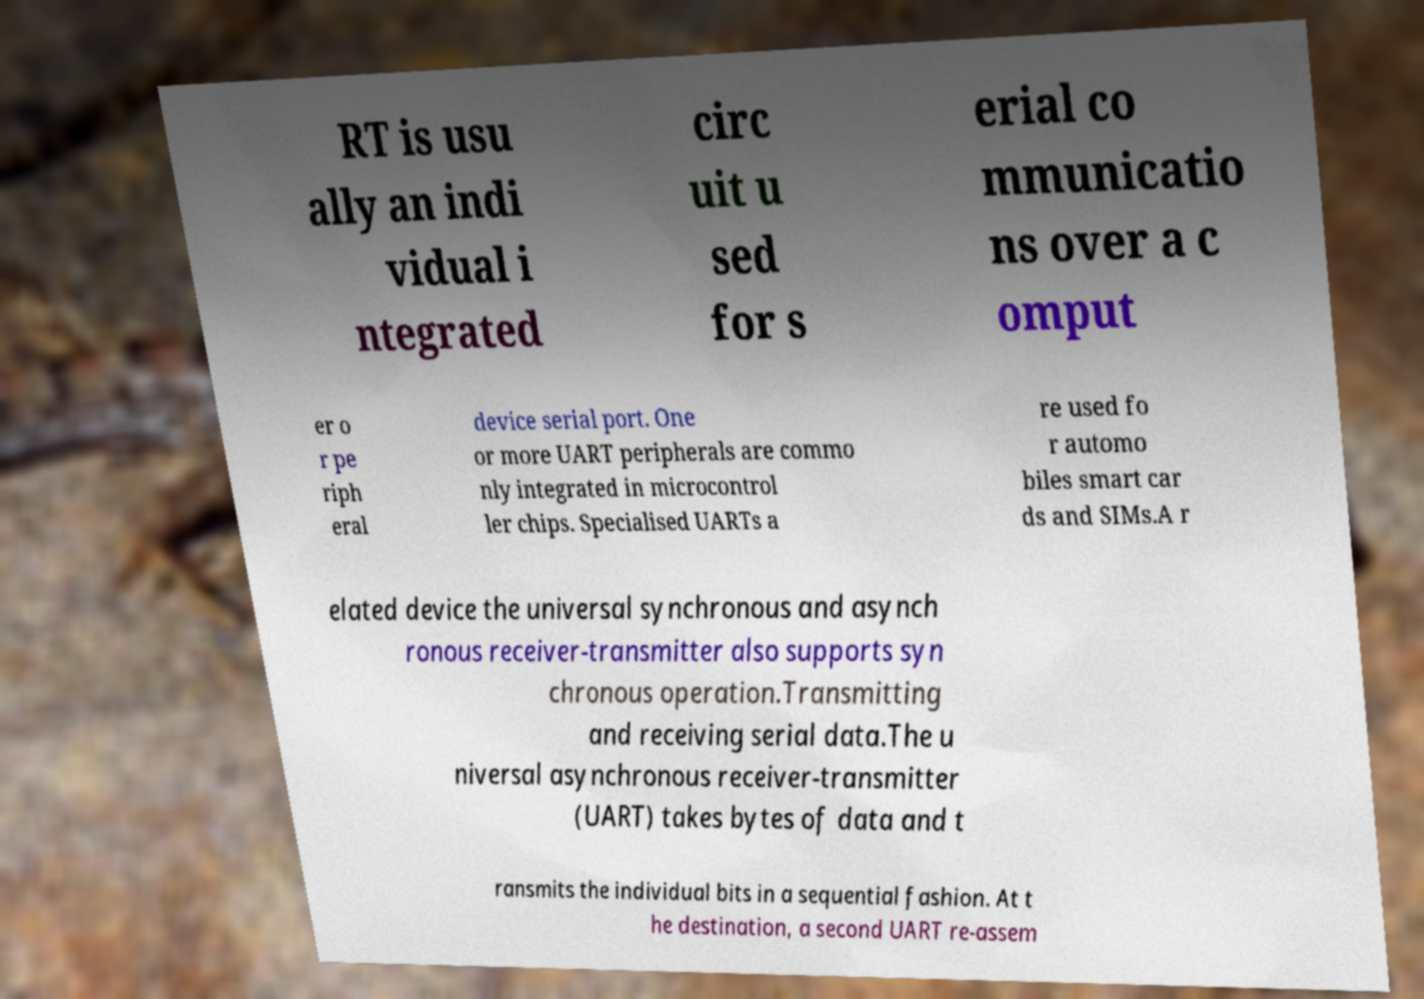Could you extract and type out the text from this image? RT is usu ally an indi vidual i ntegrated circ uit u sed for s erial co mmunicatio ns over a c omput er o r pe riph eral device serial port. One or more UART peripherals are commo nly integrated in microcontrol ler chips. Specialised UARTs a re used fo r automo biles smart car ds and SIMs.A r elated device the universal synchronous and asynch ronous receiver-transmitter also supports syn chronous operation.Transmitting and receiving serial data.The u niversal asynchronous receiver-transmitter (UART) takes bytes of data and t ransmits the individual bits in a sequential fashion. At t he destination, a second UART re-assem 